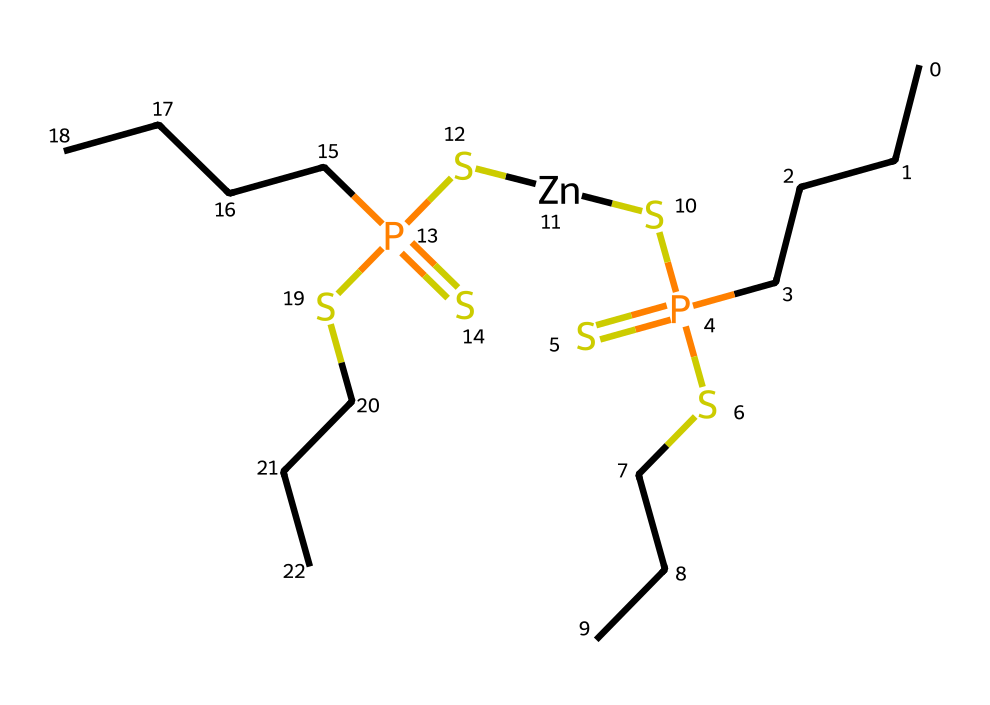what is the primary functional group present in this molecule? The chemical structure includes a phosphorothioate as indicated by the presence of phosphorus and sulfur atoms, which are intrinsic to the functional group that characterizes phosphorothioates.
Answer: phosphorothioate how many sulfur atoms are in this structure? By examining the SMILES representation, we can count the sulfur atoms denoted by the letter 'S.' There are four instances of 'S' indicating four sulfur atoms in the molecule.
Answer: four what is the role of zinc in this chemical? Zinc is commonly used as a catalytic or protective additive in lubricants, helping to enhance the lubricant's properties by providing anti-corrosive and anti-wear benefits.
Answer: anti-corrosive how many carbon chains are present in this molecule? Analyzing the SMILES, there are three occurrences of 'CCC' as well as 'CCCC', indicating that there are four carbon chains in total within the structure.
Answer: four what type of lubricant additive does this chemical represent? The presence of phosphorus and sulfur suggests that this compound serves as an extreme pressure additive or anti-wear additive in lubricants, which is crucial for high-stress conditions.
Answer: extreme pressure additive what is the total number of phosphorus atoms in this structure? The SMILES contains 'P(=S)' twice, indicating two phosphorus atoms in total; thus, there are two phosphorus atoms.
Answer: two what implications does the presence of phosphorus and sulfur have for lubricant performance? The combination of phosphorus and sulfur in lubricants typically enhances anti-wear properties, provides film strength, and helps prevent metal-to-metal contact under high pressure.
Answer: enhances performance 